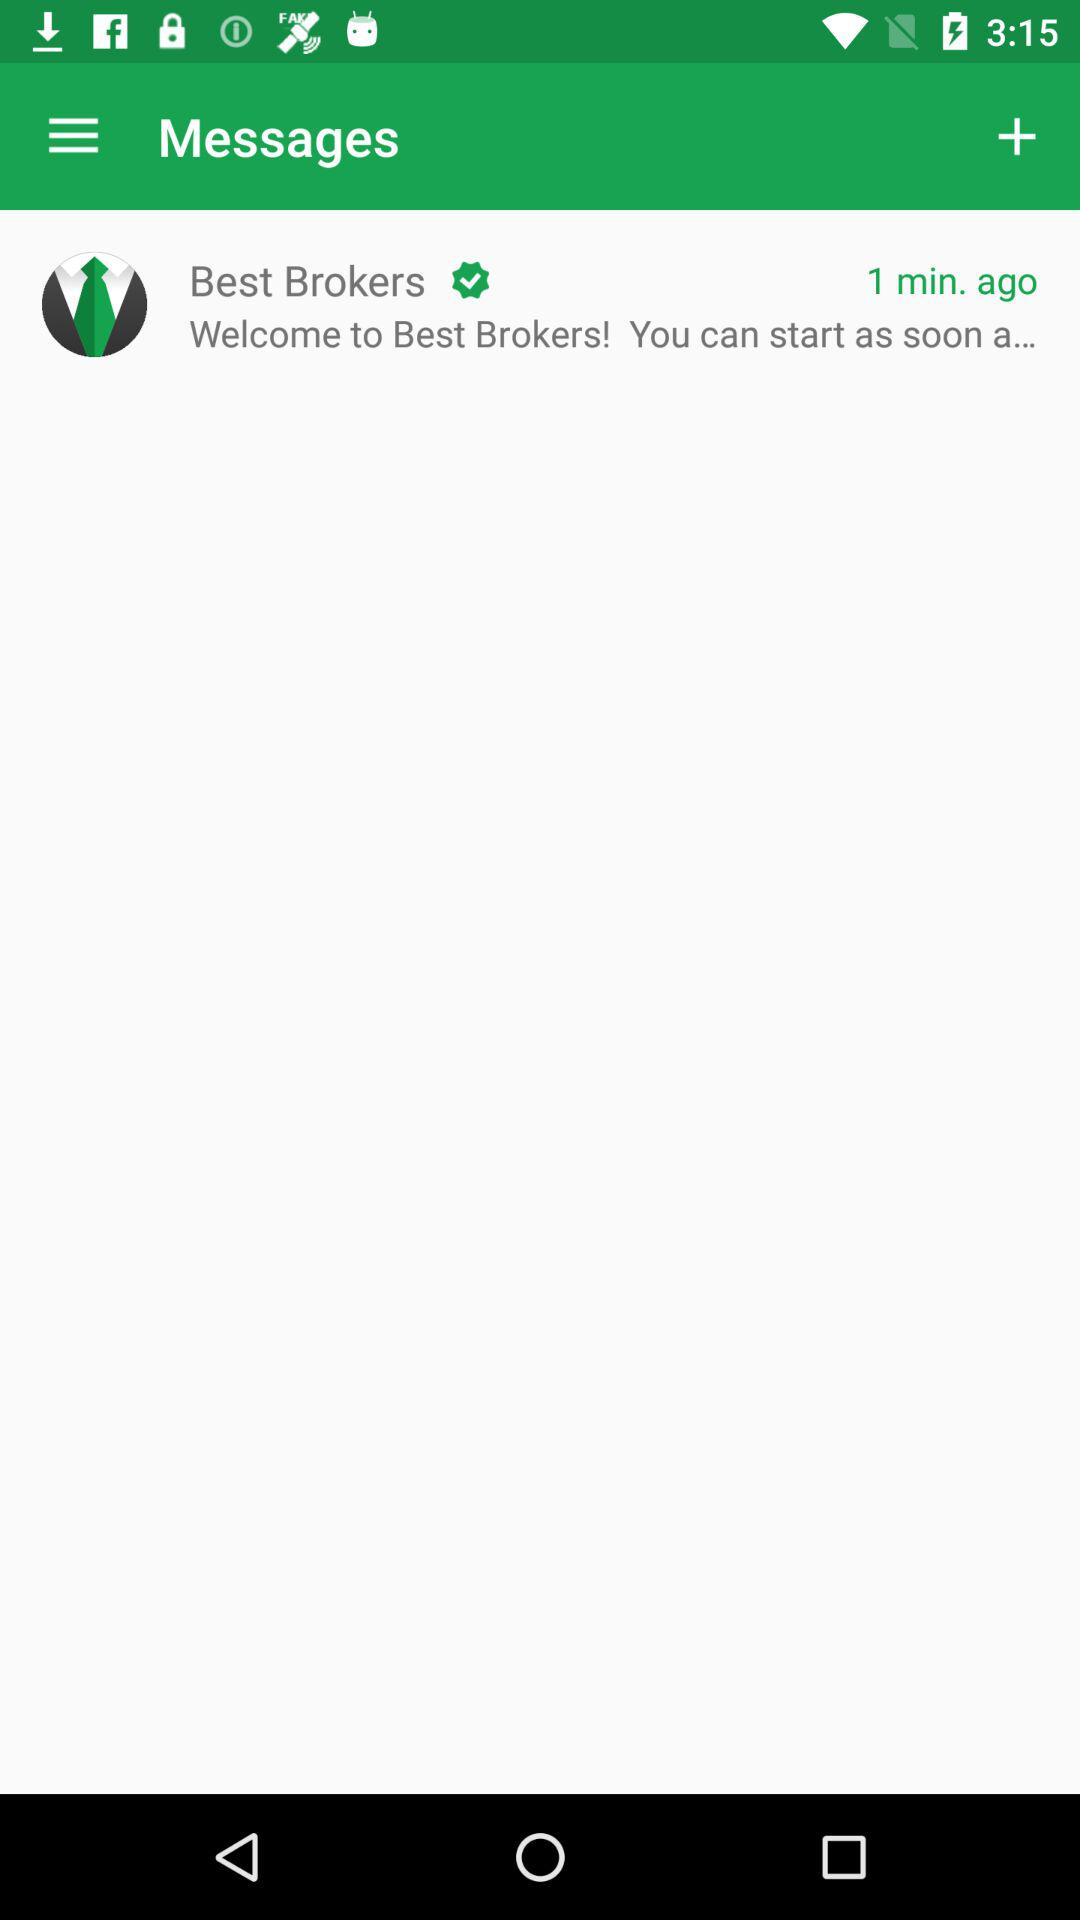When was the last message received? The last message was received 1 minute ago. 